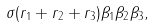Convert formula to latex. <formula><loc_0><loc_0><loc_500><loc_500>\sigma ( r _ { 1 } + r _ { 2 } + r _ { 3 } ) \beta _ { 1 } \beta _ { 2 } \beta _ { 3 } ,</formula> 